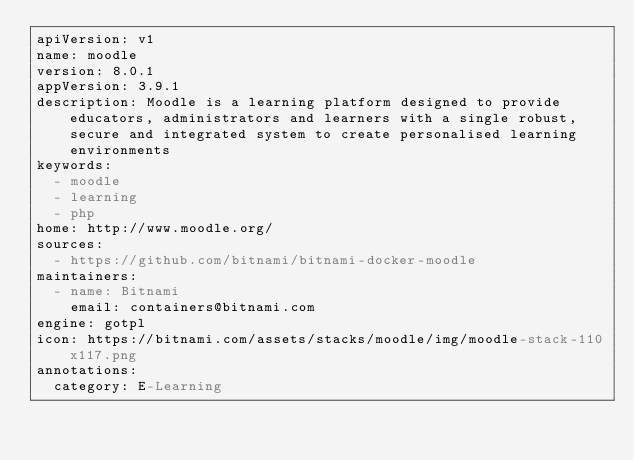<code> <loc_0><loc_0><loc_500><loc_500><_YAML_>apiVersion: v1
name: moodle
version: 8.0.1
appVersion: 3.9.1
description: Moodle is a learning platform designed to provide educators, administrators and learners with a single robust, secure and integrated system to create personalised learning environments
keywords:
  - moodle
  - learning
  - php
home: http://www.moodle.org/
sources:
  - https://github.com/bitnami/bitnami-docker-moodle
maintainers:
  - name: Bitnami
    email: containers@bitnami.com
engine: gotpl
icon: https://bitnami.com/assets/stacks/moodle/img/moodle-stack-110x117.png
annotations:
  category: E-Learning
</code> 